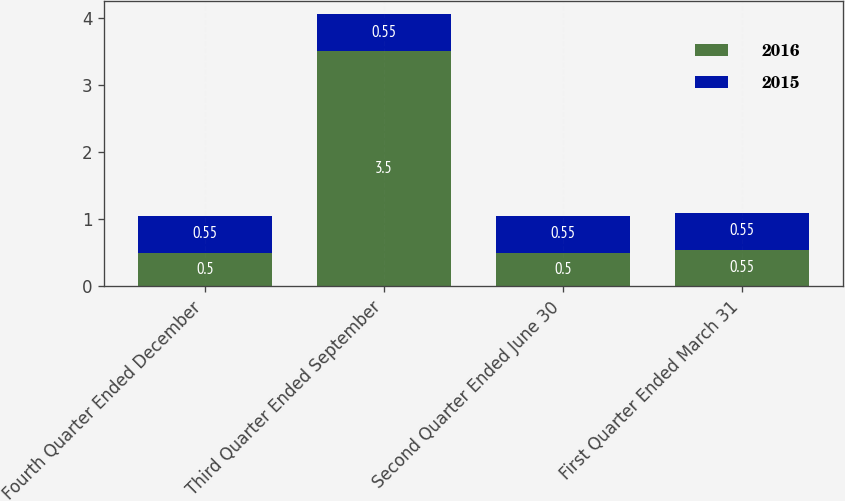Convert chart. <chart><loc_0><loc_0><loc_500><loc_500><stacked_bar_chart><ecel><fcel>Fourth Quarter Ended December<fcel>Third Quarter Ended September<fcel>Second Quarter Ended June 30<fcel>First Quarter Ended March 31<nl><fcel>2016<fcel>0.5<fcel>3.5<fcel>0.5<fcel>0.55<nl><fcel>2015<fcel>0.55<fcel>0.55<fcel>0.55<fcel>0.55<nl></chart> 